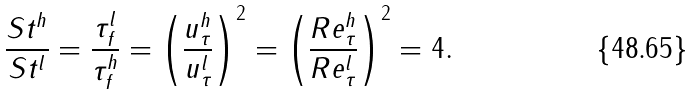<formula> <loc_0><loc_0><loc_500><loc_500>\frac { S t ^ { h } } { S t ^ { l } } = \frac { \tau _ { f } ^ { l } } { \tau _ { f } ^ { h } } = \left ( \frac { u _ { \tau } ^ { h } } { u _ { \tau } ^ { l } } \right ) ^ { 2 } = \left ( \frac { R e _ { \tau } ^ { h } } { R e _ { \tau } ^ { l } } \right ) ^ { 2 } = 4 .</formula> 